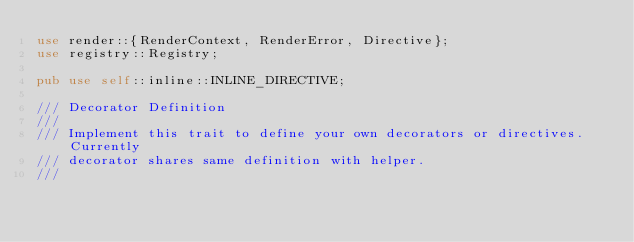Convert code to text. <code><loc_0><loc_0><loc_500><loc_500><_Rust_>use render::{RenderContext, RenderError, Directive};
use registry::Registry;

pub use self::inline::INLINE_DIRECTIVE;

/// Decorator Definition
///
/// Implement this trait to define your own decorators or directives. Currently
/// decorator shares same definition with helper.
///</code> 